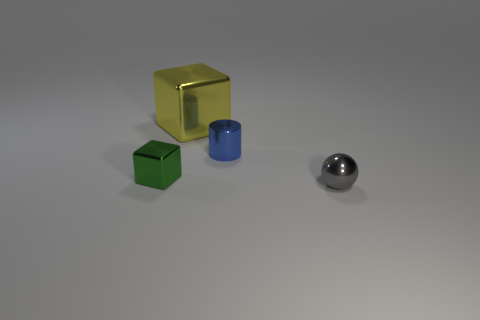There is a cube in front of the yellow shiny object; what material is it?
Your response must be concise. Metal. What is the shape of the small metal thing behind the metal block in front of the shiny cube that is to the right of the tiny block?
Offer a terse response. Cylinder. Do the gray metal sphere and the blue cylinder have the same size?
Keep it short and to the point. Yes. How many things are large objects or tiny shiny things on the right side of the green thing?
Your answer should be compact. 3. What number of objects are either small metallic objects to the left of the metallic sphere or big metal things that are on the left side of the tiny ball?
Your answer should be compact. 3. There is a big yellow metal object; are there any small things behind it?
Offer a very short reply. No. The thing left of the metal block behind the metallic object on the left side of the big yellow object is what color?
Provide a short and direct response. Green. Does the small blue object have the same shape as the yellow metallic object?
Offer a very short reply. No. There is a large block that is the same material as the tiny green object; what is its color?
Offer a terse response. Yellow. How many things are tiny things that are to the right of the tiny blue cylinder or tiny shiny spheres?
Ensure brevity in your answer.  1. 